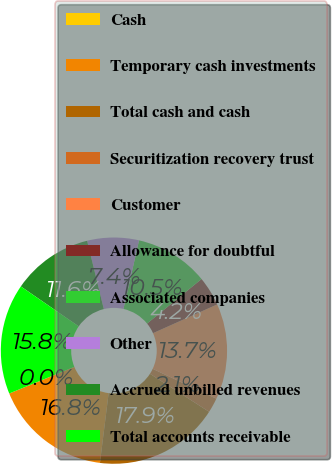Convert chart. <chart><loc_0><loc_0><loc_500><loc_500><pie_chart><fcel>Cash<fcel>Temporary cash investments<fcel>Total cash and cash<fcel>Securitization recovery trust<fcel>Customer<fcel>Allowance for doubtful<fcel>Associated companies<fcel>Other<fcel>Accrued unbilled revenues<fcel>Total accounts receivable<nl><fcel>0.0%<fcel>16.84%<fcel>17.89%<fcel>2.11%<fcel>13.68%<fcel>4.21%<fcel>10.53%<fcel>7.37%<fcel>11.58%<fcel>15.79%<nl></chart> 